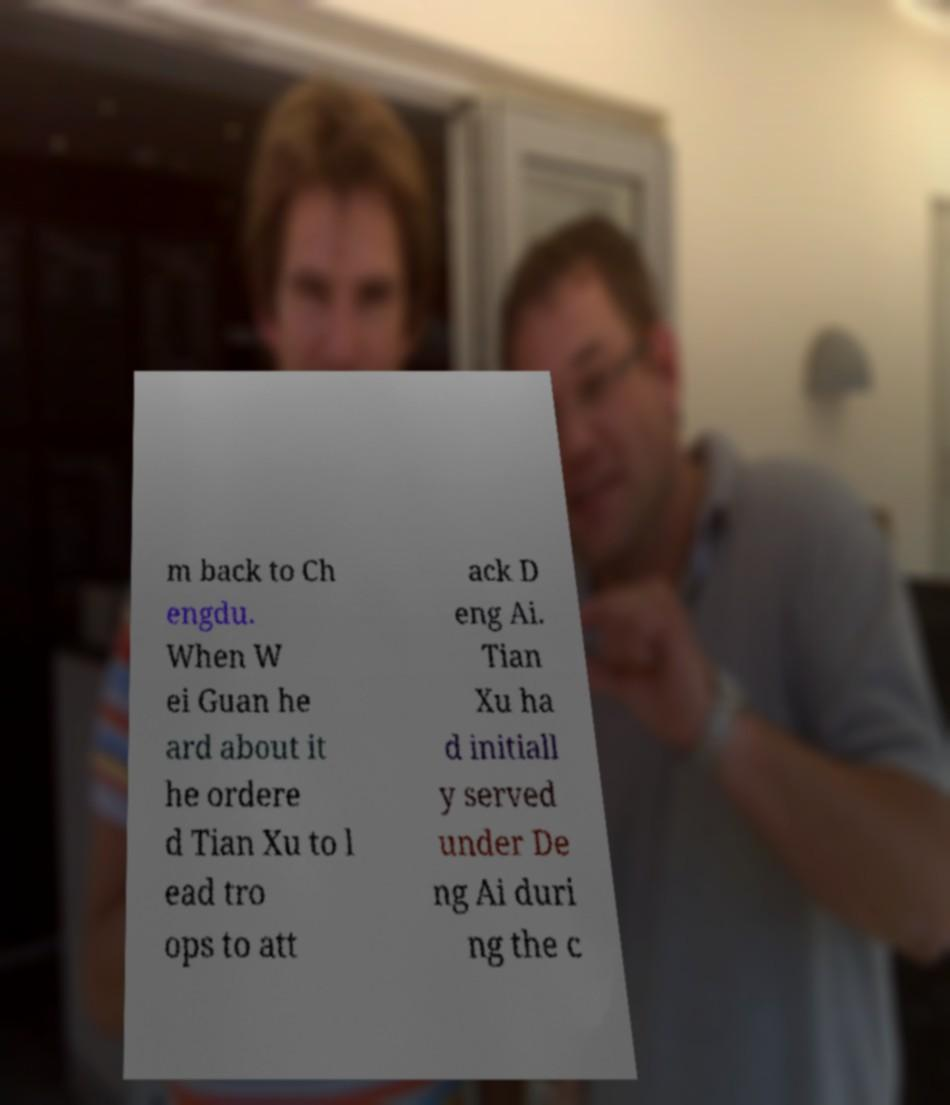Can you accurately transcribe the text from the provided image for me? m back to Ch engdu. When W ei Guan he ard about it he ordere d Tian Xu to l ead tro ops to att ack D eng Ai. Tian Xu ha d initiall y served under De ng Ai duri ng the c 